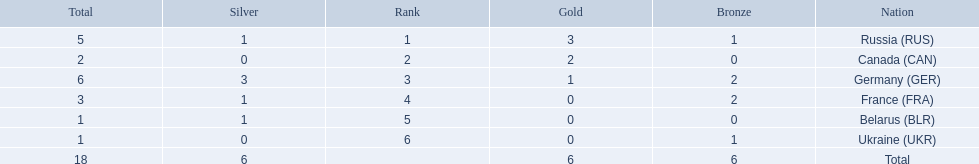Which nations participated? Russia (RUS), Canada (CAN), Germany (GER), France (FRA), Belarus (BLR), Ukraine (UKR). And how many gold medals did they win? 3, 2, 1, 0, 0, 0. What about silver medals? 1, 0, 3, 1, 1, 0. And bronze? 1, 0, 2, 2, 0, 1. Parse the full table. {'header': ['Total', 'Silver', 'Rank', 'Gold', 'Bronze', 'Nation'], 'rows': [['5', '1', '1', '3', '1', 'Russia\xa0(RUS)'], ['2', '0', '2', '2', '0', 'Canada\xa0(CAN)'], ['6', '3', '3', '1', '2', 'Germany\xa0(GER)'], ['3', '1', '4', '0', '2', 'France\xa0(FRA)'], ['1', '1', '5', '0', '0', 'Belarus\xa0(BLR)'], ['1', '0', '6', '0', '1', 'Ukraine\xa0(UKR)'], ['18', '6', '', '6', '6', 'Total']]} Which nation only won gold medals? Canada (CAN). 